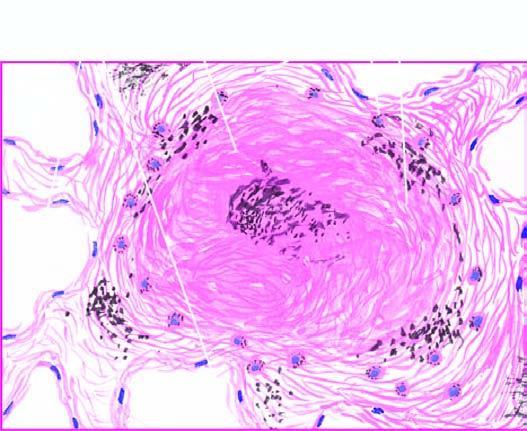what shows bright fibres of silica?
Answer the question using a single word or phrase. Polarising microscopy in photomicrograph on right 